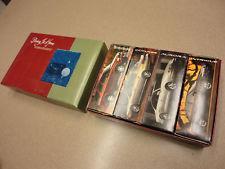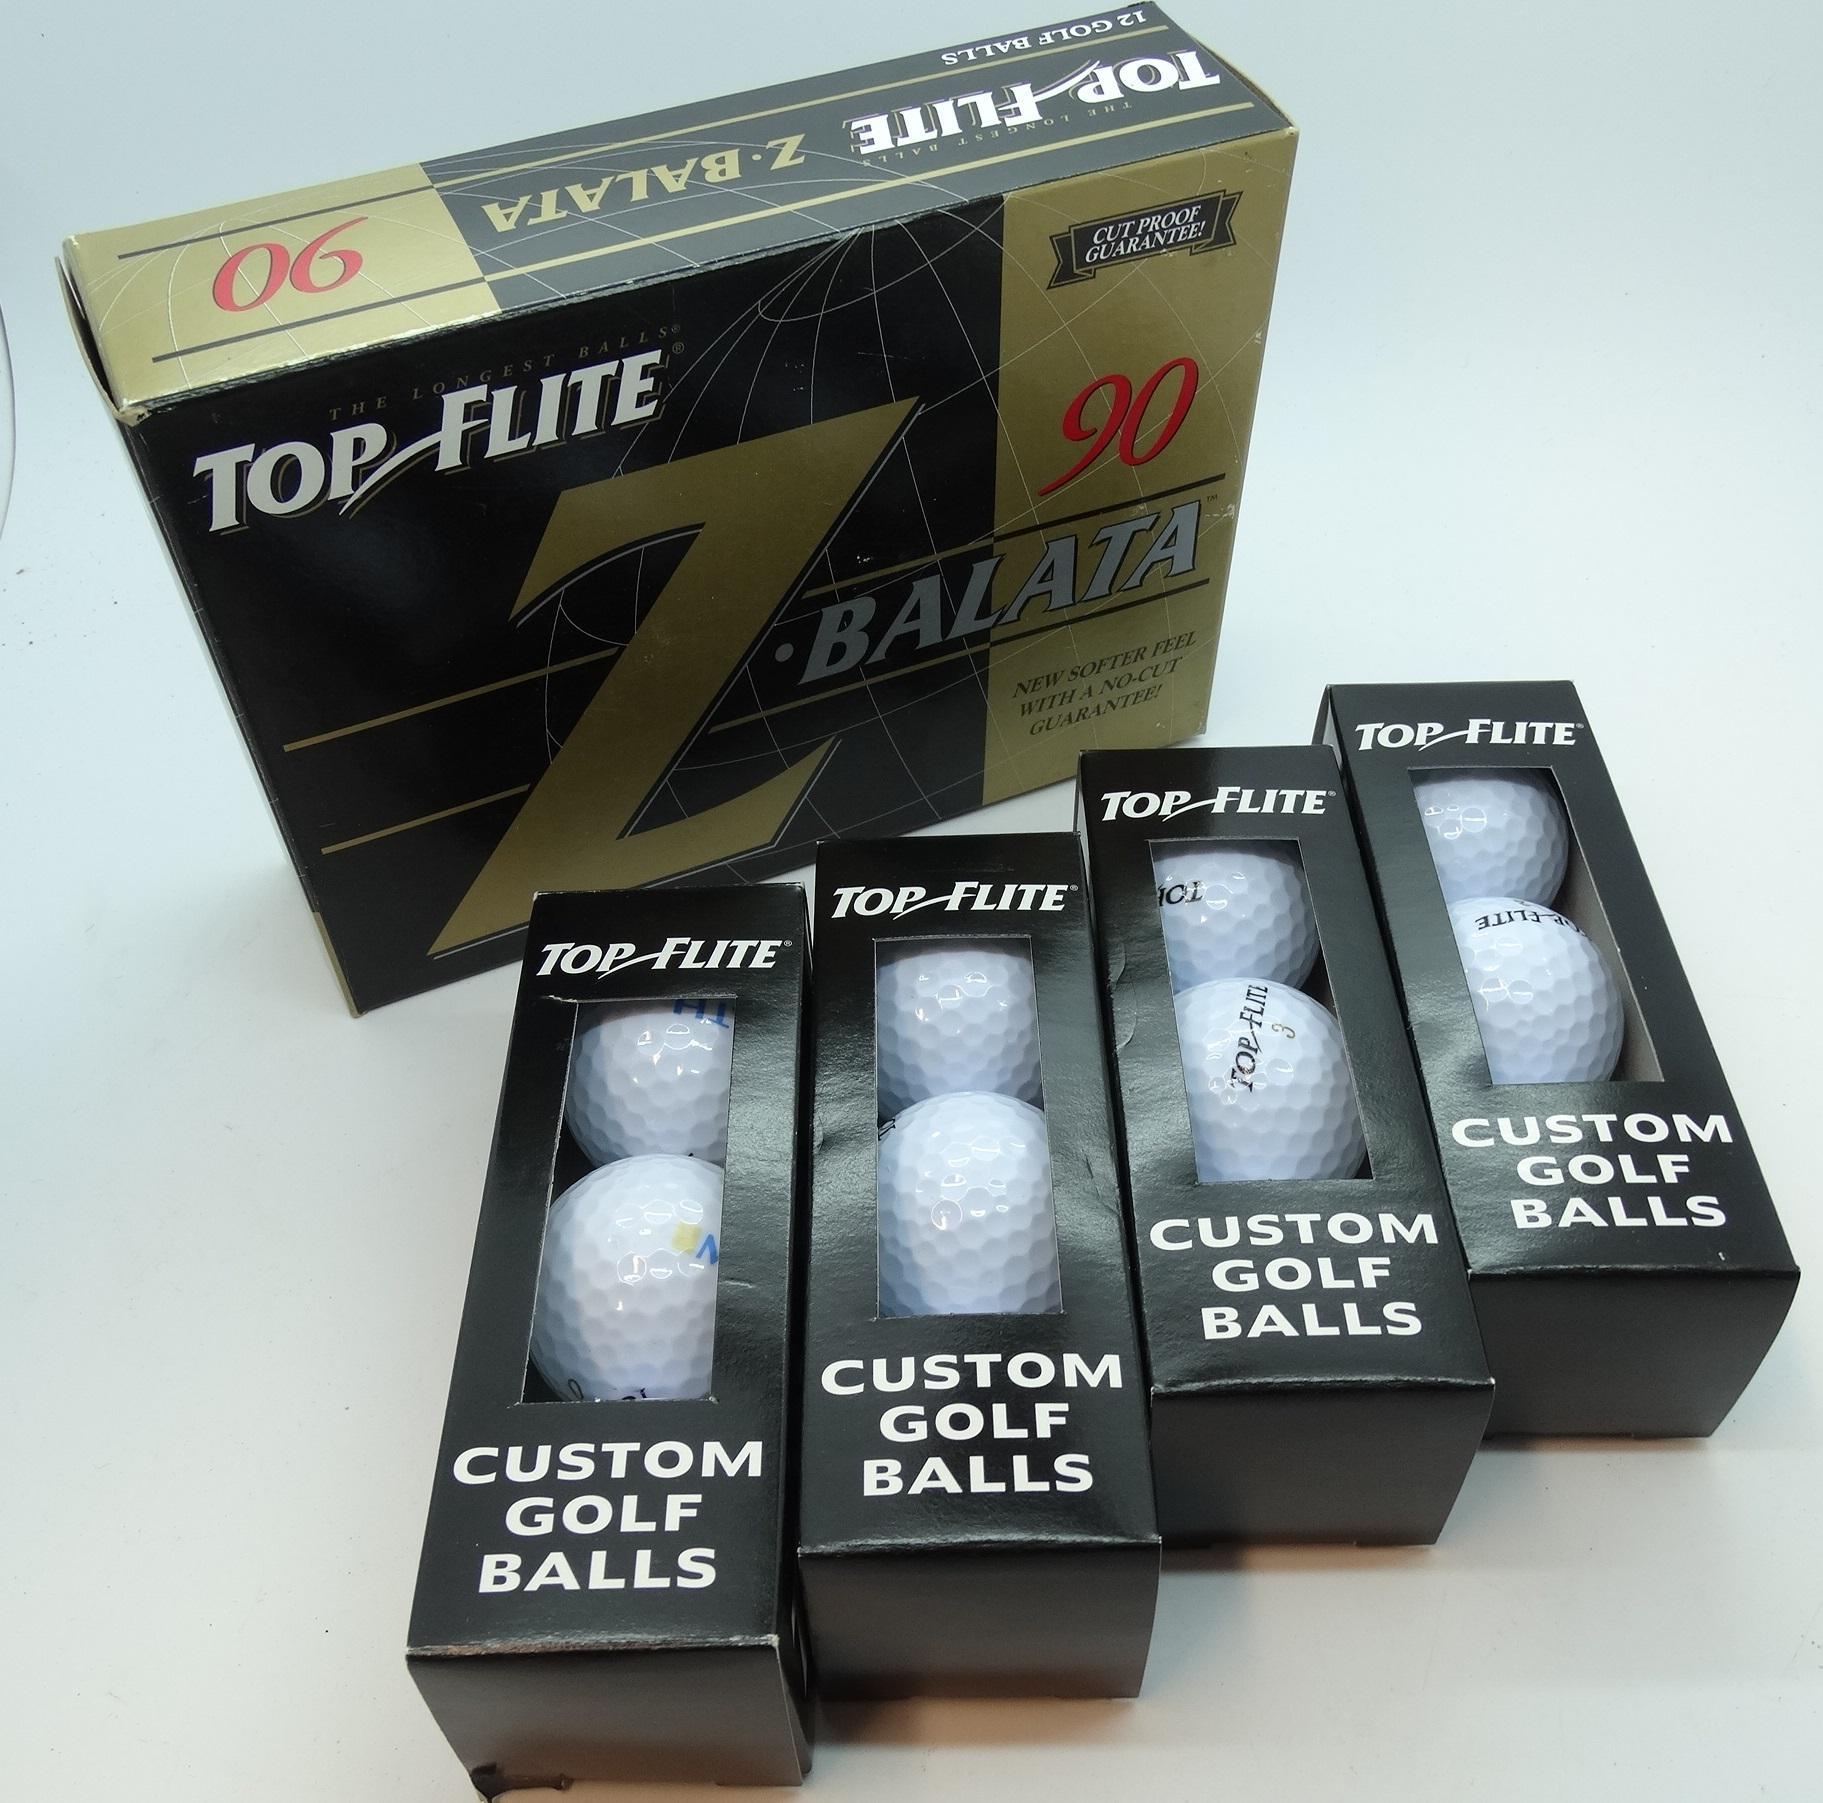The first image is the image on the left, the second image is the image on the right. For the images shown, is this caption "All of the golf balls are inside boxes." true? Answer yes or no. Yes. The first image is the image on the left, the second image is the image on the right. For the images displayed, is the sentence "An image includes at least one golf ball out of its package, next to a box made to hold a few balls." factually correct? Answer yes or no. No. 